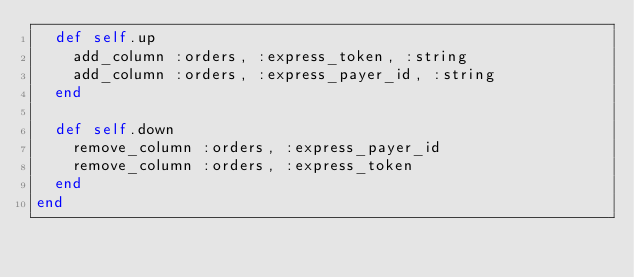Convert code to text. <code><loc_0><loc_0><loc_500><loc_500><_Ruby_>  def self.up
    add_column :orders, :express_token, :string
    add_column :orders, :express_payer_id, :string
  end

  def self.down
    remove_column :orders, :express_payer_id
    remove_column :orders, :express_token
  end
end
</code> 